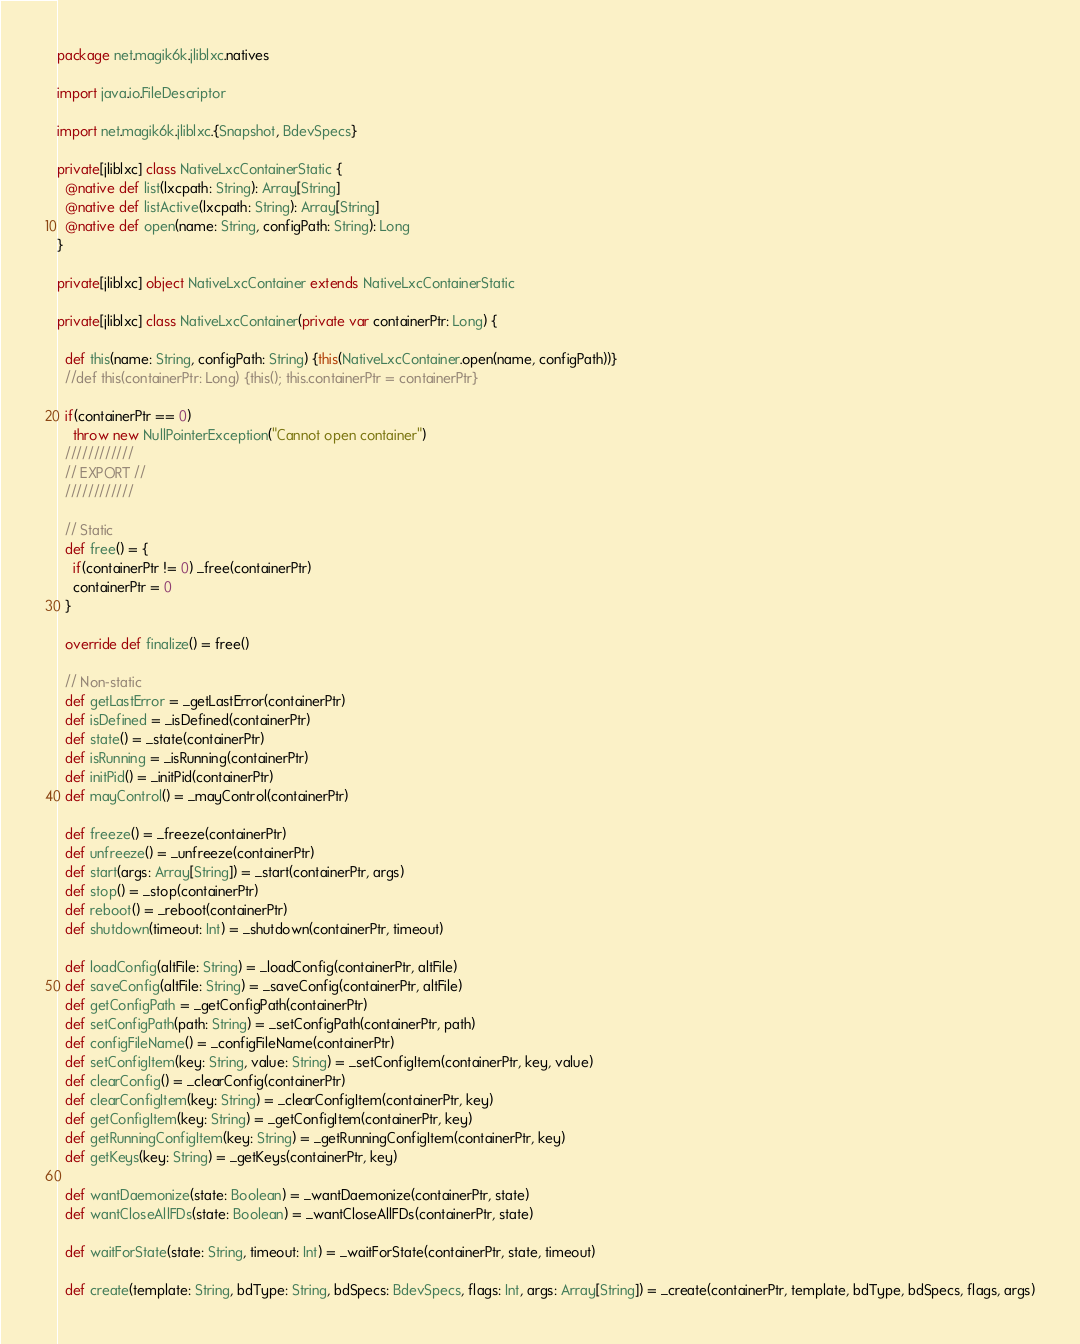Convert code to text. <code><loc_0><loc_0><loc_500><loc_500><_Scala_>package net.magik6k.jliblxc.natives

import java.io.FileDescriptor

import net.magik6k.jliblxc.{Snapshot, BdevSpecs}

private[jliblxc] class NativeLxcContainerStatic {
  @native def list(lxcpath: String): Array[String]
  @native def listActive(lxcpath: String): Array[String]
  @native def open(name: String, configPath: String): Long
}

private[jliblxc] object NativeLxcContainer extends NativeLxcContainerStatic

private[jliblxc] class NativeLxcContainer(private var containerPtr: Long) {

  def this(name: String, configPath: String) {this(NativeLxcContainer.open(name, configPath))}
  //def this(containerPtr: Long) {this(); this.containerPtr = containerPtr}

  if(containerPtr == 0)
    throw new NullPointerException("Cannot open container")
  ////////////
  // EXPORT //
  ////////////

  // Static
  def free() = {
    if(containerPtr != 0) _free(containerPtr)
    containerPtr = 0
  }

  override def finalize() = free()

  // Non-static
  def getLastError = _getLastError(containerPtr)
  def isDefined = _isDefined(containerPtr)
  def state() = _state(containerPtr)
  def isRunning = _isRunning(containerPtr)
  def initPid() = _initPid(containerPtr)
  def mayControl() = _mayControl(containerPtr)

  def freeze() = _freeze(containerPtr)
  def unfreeze() = _unfreeze(containerPtr)
  def start(args: Array[String]) = _start(containerPtr, args)
  def stop() = _stop(containerPtr)
  def reboot() = _reboot(containerPtr)
  def shutdown(timeout: Int) = _shutdown(containerPtr, timeout)

  def loadConfig(altFile: String) = _loadConfig(containerPtr, altFile)
  def saveConfig(altFile: String) = _saveConfig(containerPtr, altFile)
  def getConfigPath = _getConfigPath(containerPtr)
  def setConfigPath(path: String) = _setConfigPath(containerPtr, path)
  def configFileName() = _configFileName(containerPtr)
  def setConfigItem(key: String, value: String) = _setConfigItem(containerPtr, key, value)
  def clearConfig() = _clearConfig(containerPtr)
  def clearConfigItem(key: String) = _clearConfigItem(containerPtr, key)
  def getConfigItem(key: String) = _getConfigItem(containerPtr, key)
  def getRunningConfigItem(key: String) = _getRunningConfigItem(containerPtr, key)
  def getKeys(key: String) = _getKeys(containerPtr, key)

  def wantDaemonize(state: Boolean) = _wantDaemonize(containerPtr, state)
  def wantCloseAllFDs(state: Boolean) = _wantCloseAllFDs(containerPtr, state)

  def waitForState(state: String, timeout: Int) = _waitForState(containerPtr, state, timeout)

  def create(template: String, bdType: String, bdSpecs: BdevSpecs, flags: Int, args: Array[String]) = _create(containerPtr, template, bdType, bdSpecs, flags, args)</code> 